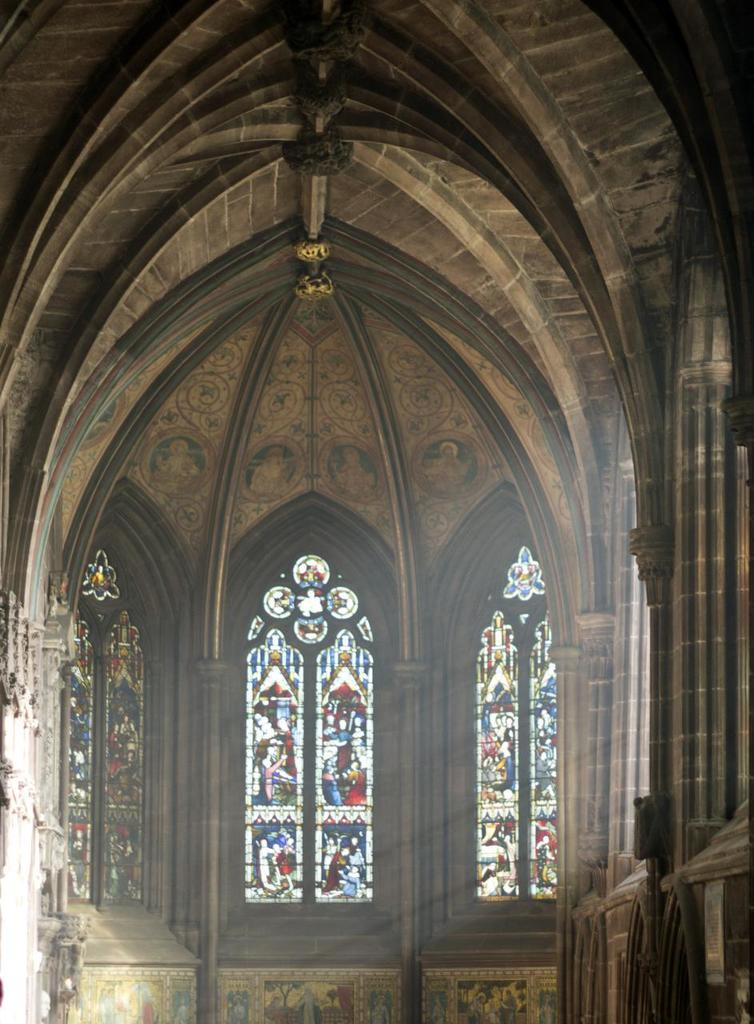What type of location is depicted in the image? The image shows an inside view of a building. What specific feature can be seen in the background of the image? There are stained glasses visible in the background of the image. How many toes are visible on the stained glasses in the image? There are no toes present on the stained glasses in the image, as they are a type of glass artwork and not a living being. 